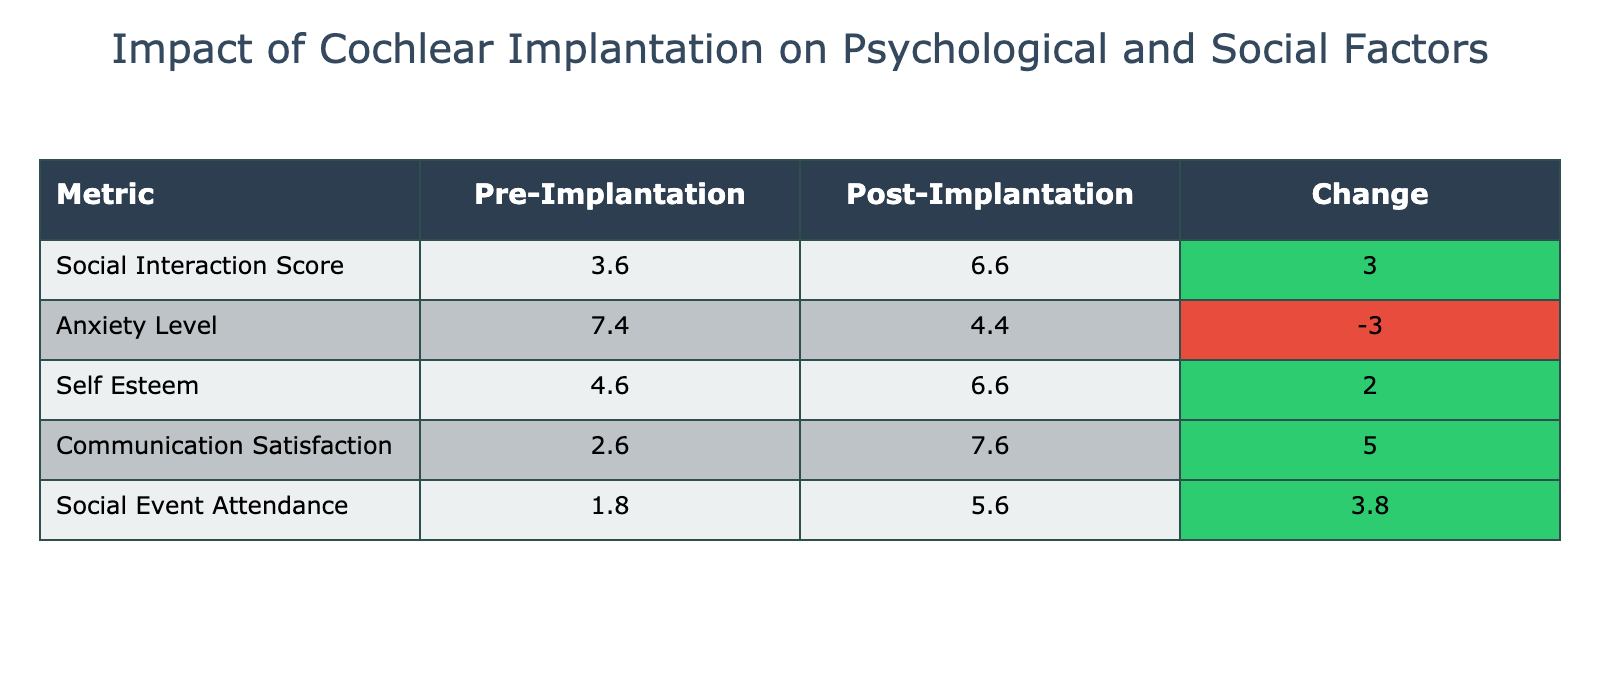What is the average Social Interaction Score before implantation? To find the average Social Interaction Score Pre, we look at the column for Social Interaction Score Pre, which contains the values: 4, 3, 5, 2, 4, 3, 5, 2, 4, 3, 5, 2, 4, 3, 5. Summing these gives  4+3+5+2+4+3+5+2+4+3+5+2+4+3+5 = 50. There are 15 participants, so the average is 50/15 = 3.33.
Answer: 3.33 What is the average Anxiety Level after implantation? To find the average Anxiety Level Post, we look at the Anxiety Level Post column: 5, 4, 3, 6, 4, 5, 3, 6, 4, 5, 3, 6, 4, 5, 3. Summing these values gives 5+4+3+6+4+5+3+6+4+5+3+6+4+5+3 = 59. Dividing by the number of participants (15) gives 59/15 = 3.93.
Answer: 3.93 Did Social Event Attendance increase for all participants after implantation? To determine if Social Event Attendance increased for all participants, we check Pre and Post values. For example, participant CI001 had a Pre value of 2 and Post value of 6, showing an increase. However, participant CI004 had Pre and Post values of 1 and 4, respectively; both improved. But participant CI010 went from 1 to 5, indicating an increase. All participants had improved attendance after implantation, so the answer is yes.
Answer: Yes What is the total change in Anxiety Level from pre to post for all participants? To find the total change in Anxiety Level, we first calculate the change for each individual by taking the Post value minus the Pre value. Summing them up: 5-8, 4-7, 3-6, 6-9, 4-7, 5-8, 3-6, 6-9, 4-7, 5-8, 3-6, 6-9, 4-7, 5-8, 3-6 gives a total of (-3) + (-3) + (-3) + (-3) + (-3) + (-3) + (-3) + (-3) + (-3) + (-3) + (-3) + (-3) + (-3) + (-3) + (-3) = -45.
Answer: -45 Was there any participant who maintained their Social Interaction Score after implantation? To find if any participant maintained their Social Interaction Score, we need to compare the Pre and Post values directly. For instance, CI004 had a Pre Score of 2 and a Post Score of 5, showing improvement, while all participants’ scores changed positively. From checking each participant, none stayed the same, every participant had a noticeable change.
Answer: No 